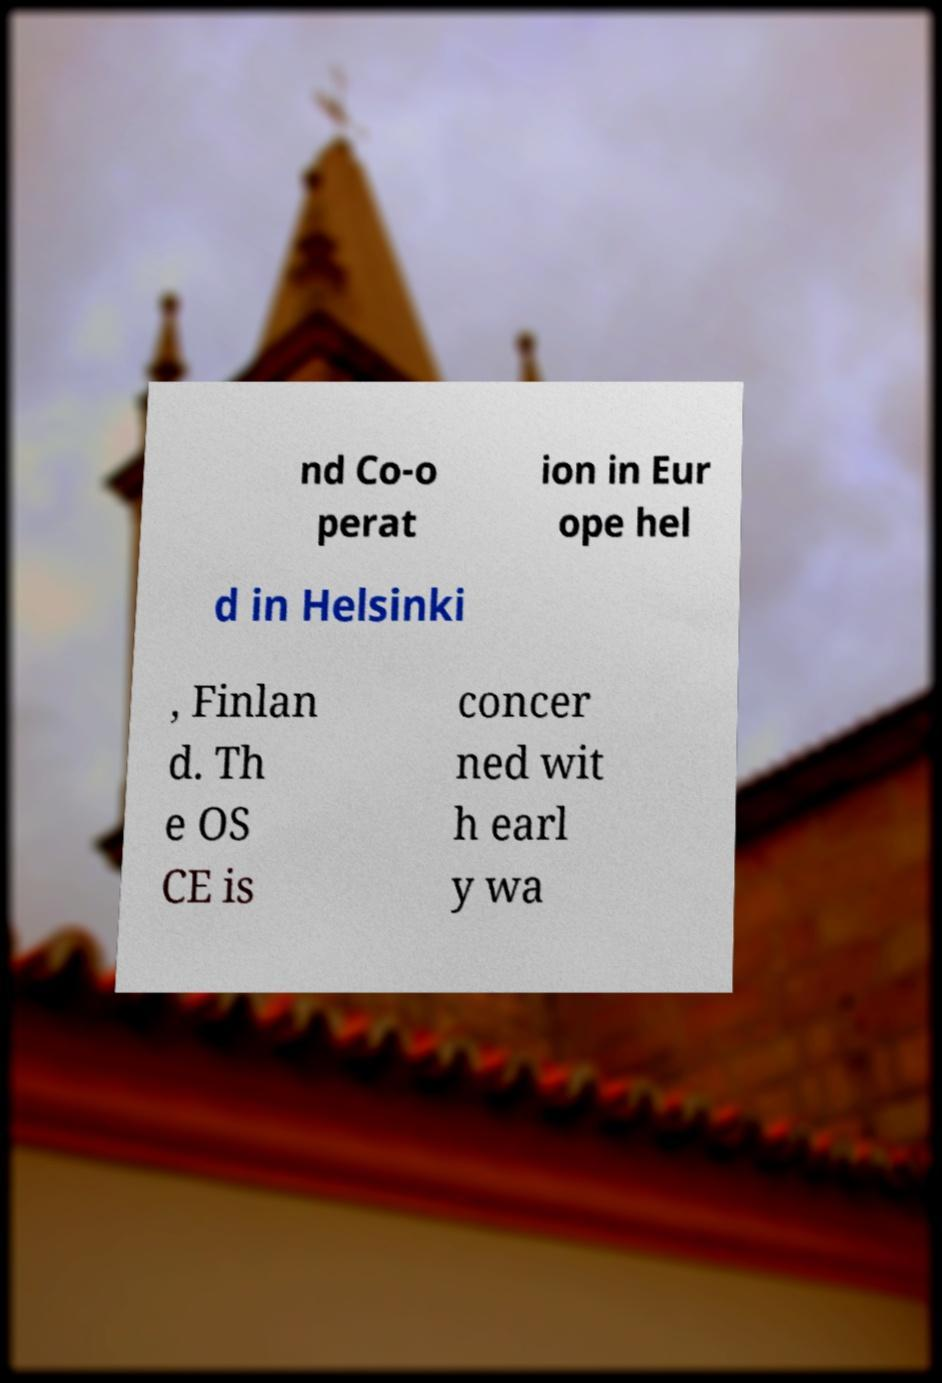Can you accurately transcribe the text from the provided image for me? nd Co-o perat ion in Eur ope hel d in Helsinki , Finlan d. Th e OS CE is concer ned wit h earl y wa 